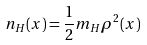<formula> <loc_0><loc_0><loc_500><loc_500>n _ { H } ( x ) = \frac { 1 } { 2 } m _ { H } \rho ^ { 2 } ( x )</formula> 